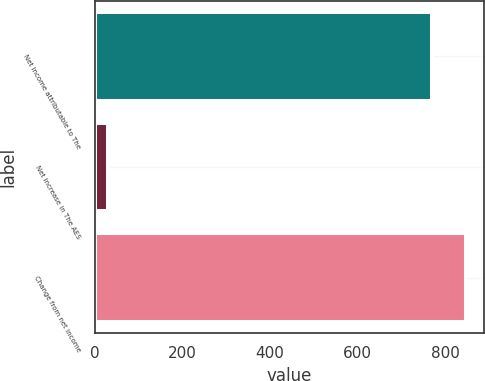Convert chart. <chart><loc_0><loc_0><loc_500><loc_500><bar_chart><fcel>Net income attributable to The<fcel>Net increase in The AES<fcel>Change from net income<nl><fcel>769<fcel>29<fcel>846.6<nl></chart> 